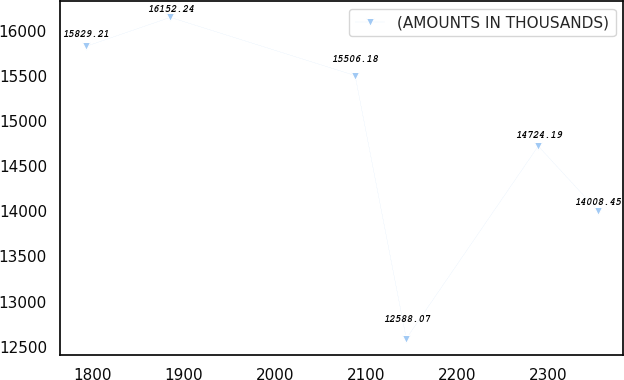Convert chart to OTSL. <chart><loc_0><loc_0><loc_500><loc_500><line_chart><ecel><fcel>(AMOUNTS IN THOUSANDS)<nl><fcel>1792.79<fcel>15829.2<nl><fcel>1885.55<fcel>16152.2<nl><fcel>2088.15<fcel>15506.2<nl><fcel>2144.27<fcel>12588.1<nl><fcel>2288.97<fcel>14724.2<nl><fcel>2354.02<fcel>14008.5<nl></chart> 